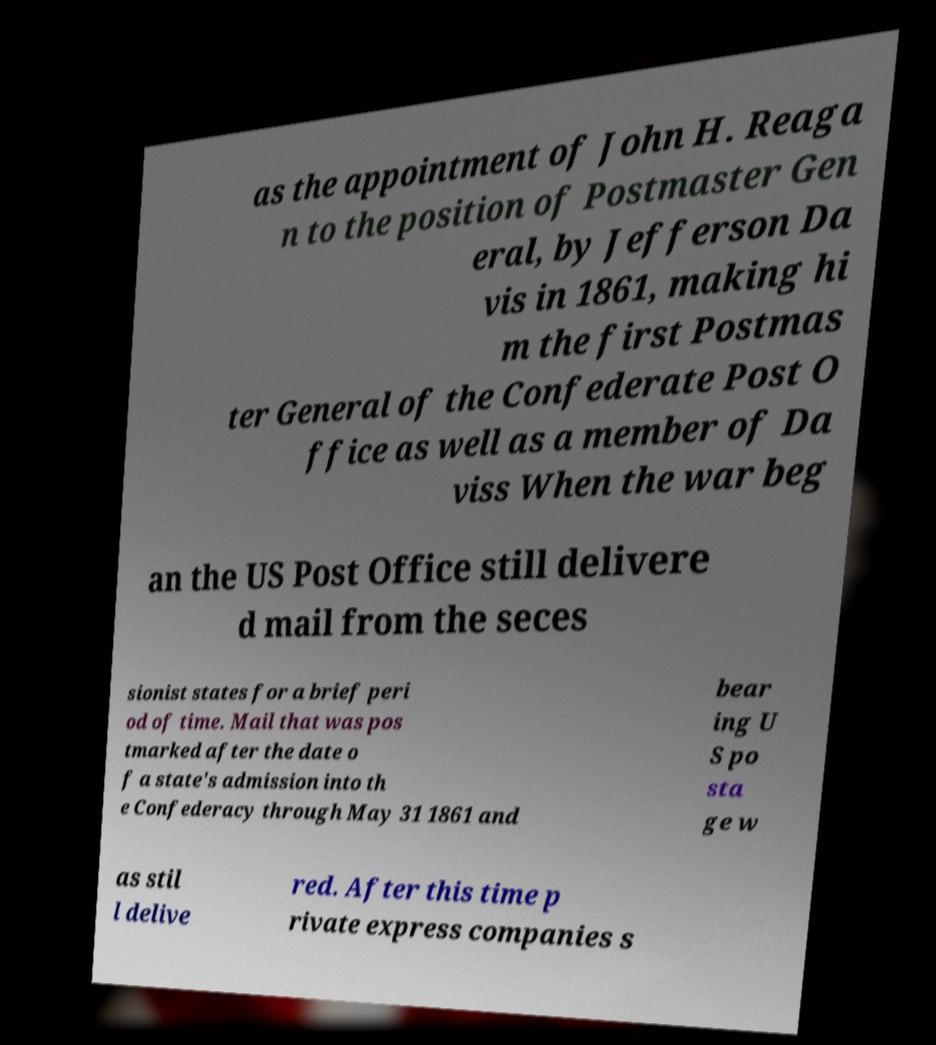Please identify and transcribe the text found in this image. as the appointment of John H. Reaga n to the position of Postmaster Gen eral, by Jefferson Da vis in 1861, making hi m the first Postmas ter General of the Confederate Post O ffice as well as a member of Da viss When the war beg an the US Post Office still delivere d mail from the seces sionist states for a brief peri od of time. Mail that was pos tmarked after the date o f a state's admission into th e Confederacy through May 31 1861 and bear ing U S po sta ge w as stil l delive red. After this time p rivate express companies s 